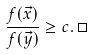<formula> <loc_0><loc_0><loc_500><loc_500>\frac { f ( \vec { x } ) } { f ( \vec { y } ) } \geq c . \, \Box</formula> 